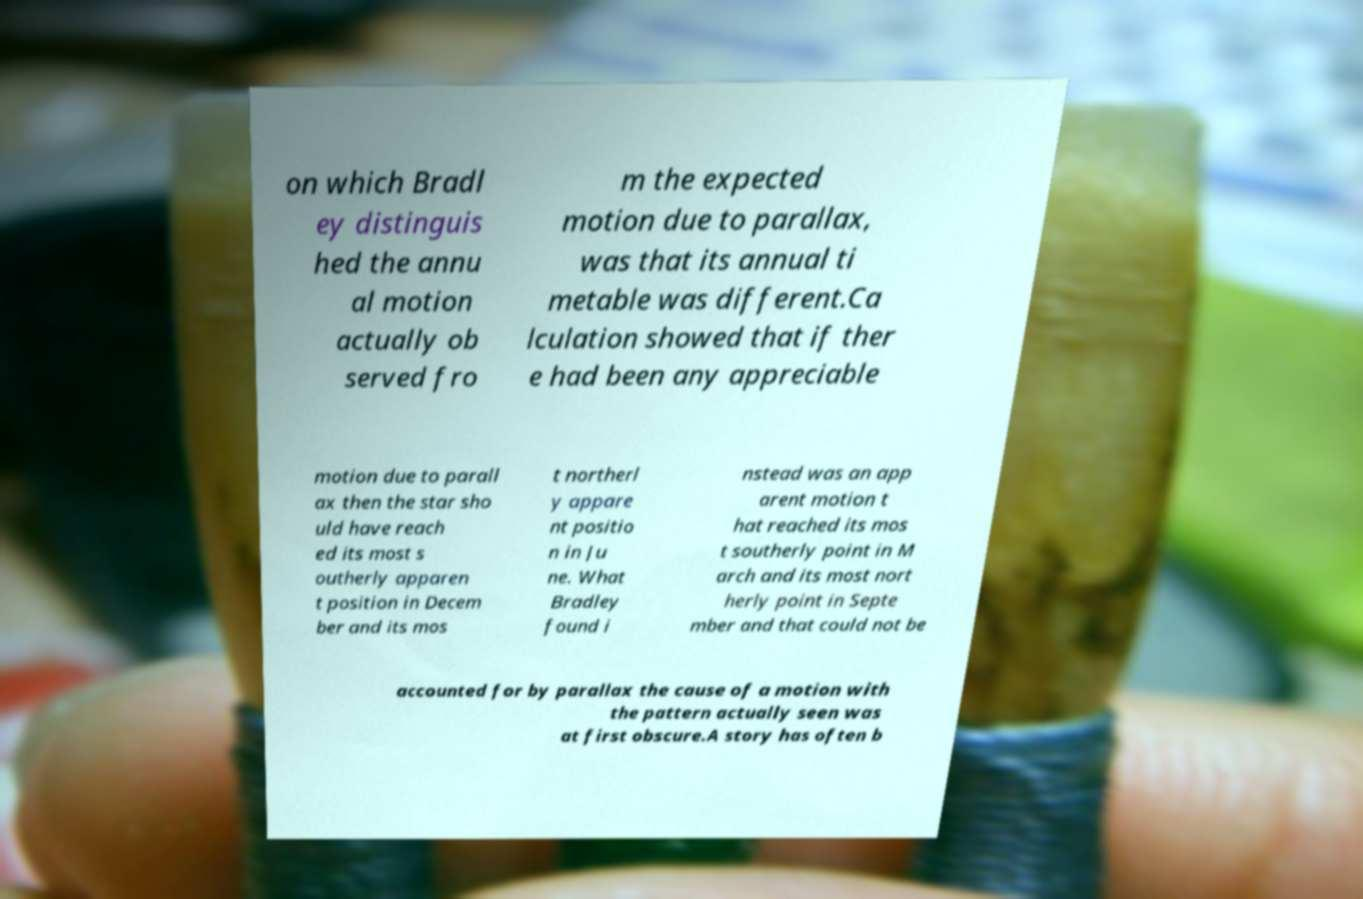What messages or text are displayed in this image? I need them in a readable, typed format. on which Bradl ey distinguis hed the annu al motion actually ob served fro m the expected motion due to parallax, was that its annual ti metable was different.Ca lculation showed that if ther e had been any appreciable motion due to parall ax then the star sho uld have reach ed its most s outherly apparen t position in Decem ber and its mos t northerl y appare nt positio n in Ju ne. What Bradley found i nstead was an app arent motion t hat reached its mos t southerly point in M arch and its most nort herly point in Septe mber and that could not be accounted for by parallax the cause of a motion with the pattern actually seen was at first obscure.A story has often b 